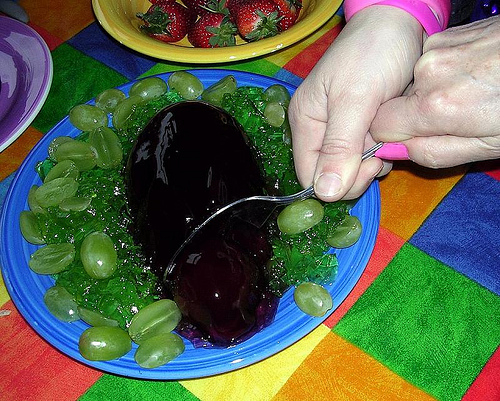<image>
Is the fork in the cranberry? Yes. The fork is contained within or inside the cranberry, showing a containment relationship. 